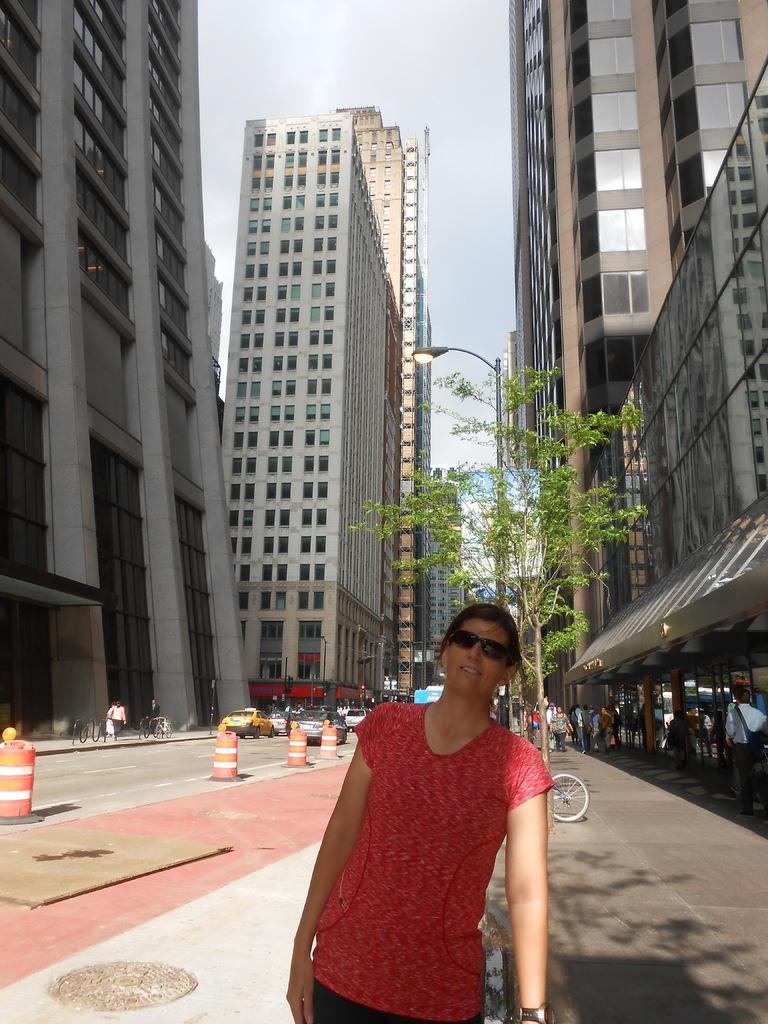Please provide a concise description of this image. This picture is clicked outside. In the foreground we can see a person wearing red color t-shirt and standing. In the center we can see the vehicles, group of persons, tree, light attached to the pole and some other objects. In the background we can see the sky, buildings, and some other objects. 